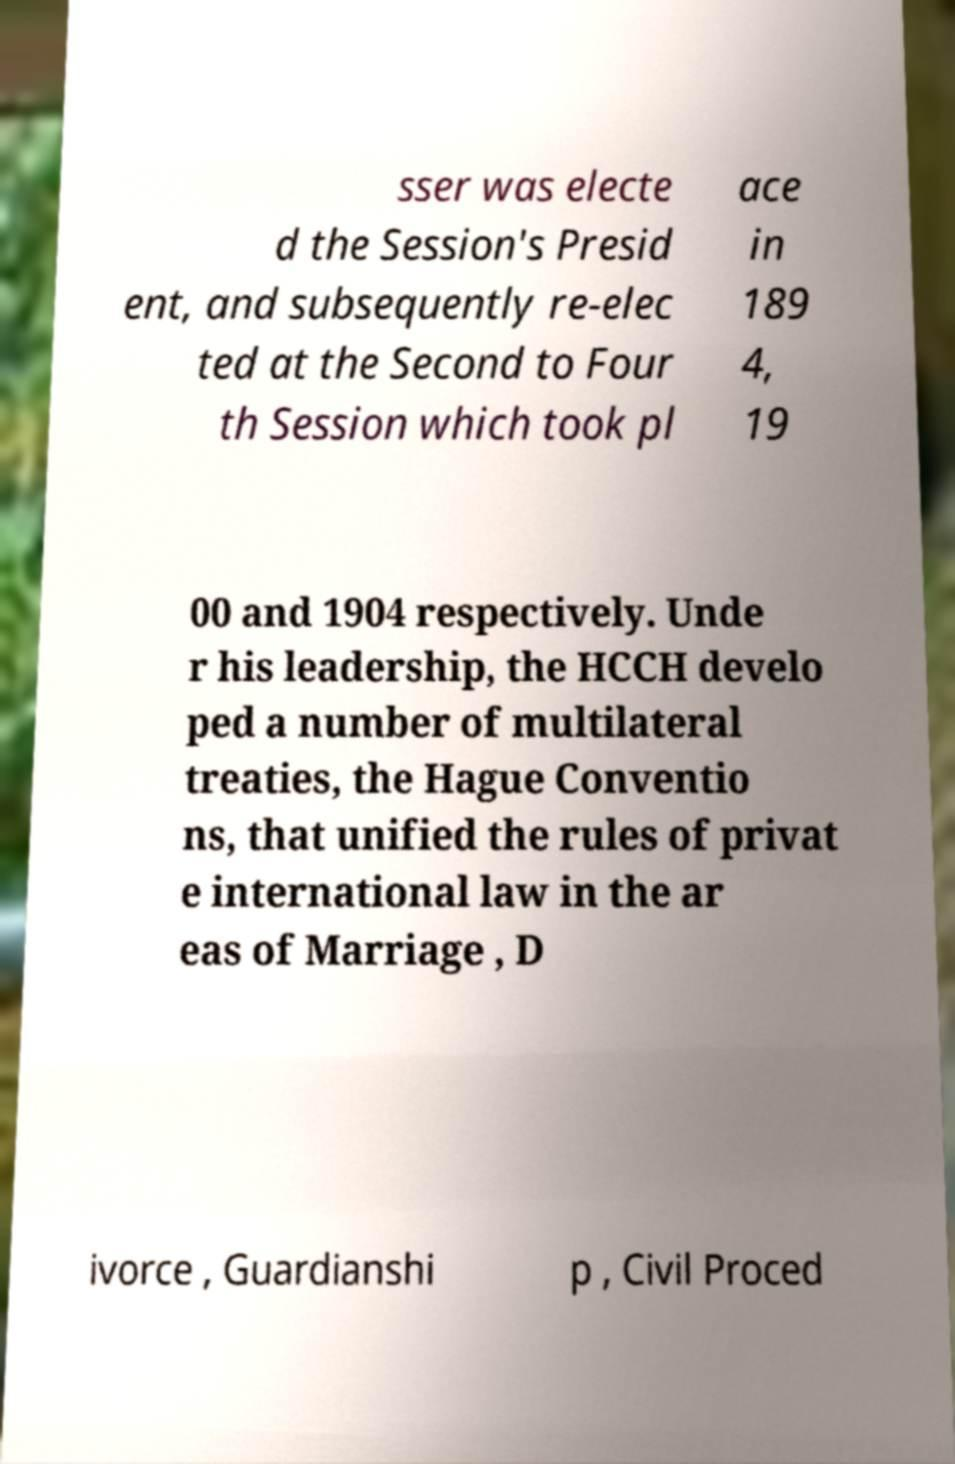Could you extract and type out the text from this image? sser was electe d the Session's Presid ent, and subsequently re-elec ted at the Second to Four th Session which took pl ace in 189 4, 19 00 and 1904 respectively. Unde r his leadership, the HCCH develo ped a number of multilateral treaties, the Hague Conventio ns, that unified the rules of privat e international law in the ar eas of Marriage , D ivorce , Guardianshi p , Civil Proced 